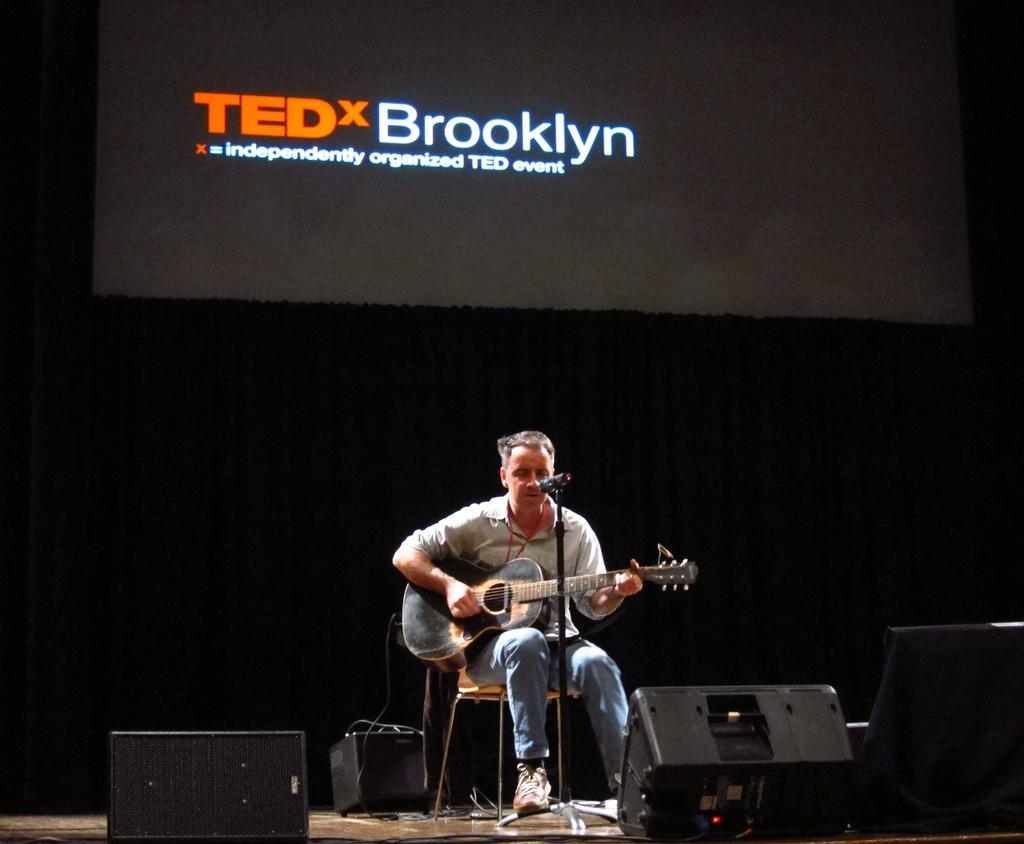What is on the curtain in the image? There is a screen on the curtain. What is the man in the image doing? The man is sitting on a chair and playing a guitar. What is in front of the man? There is a microphone in front of the man. What can be seen on the floor near the man? There are speakers on the floor. What type of pot is being used to create a musical experience in the image? There is no pot present in the image, and no musical experience involving a pot is depicted. Is there a chain attached to the guitar in the image? There is no chain visible in the image, and no chain is mentioned in the provided facts. 